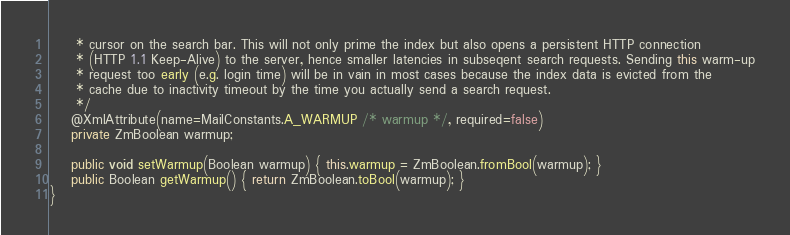<code> <loc_0><loc_0><loc_500><loc_500><_Java_>     * cursor on the search bar. This will not only prime the index but also opens a persistent HTTP connection
     * (HTTP 1.1 Keep-Alive) to the server, hence smaller latencies in subseqent search requests. Sending this warm-up
     * request too early (e.g. login time) will be in vain in most cases because the index data is evicted from the
     * cache due to inactivity timeout by the time you actually send a search request.
     */
    @XmlAttribute(name=MailConstants.A_WARMUP /* warmup */, required=false)
    private ZmBoolean warmup;

    public void setWarmup(Boolean warmup) { this.warmup = ZmBoolean.fromBool(warmup); }
    public Boolean getWarmup() { return ZmBoolean.toBool(warmup); }
}
</code> 